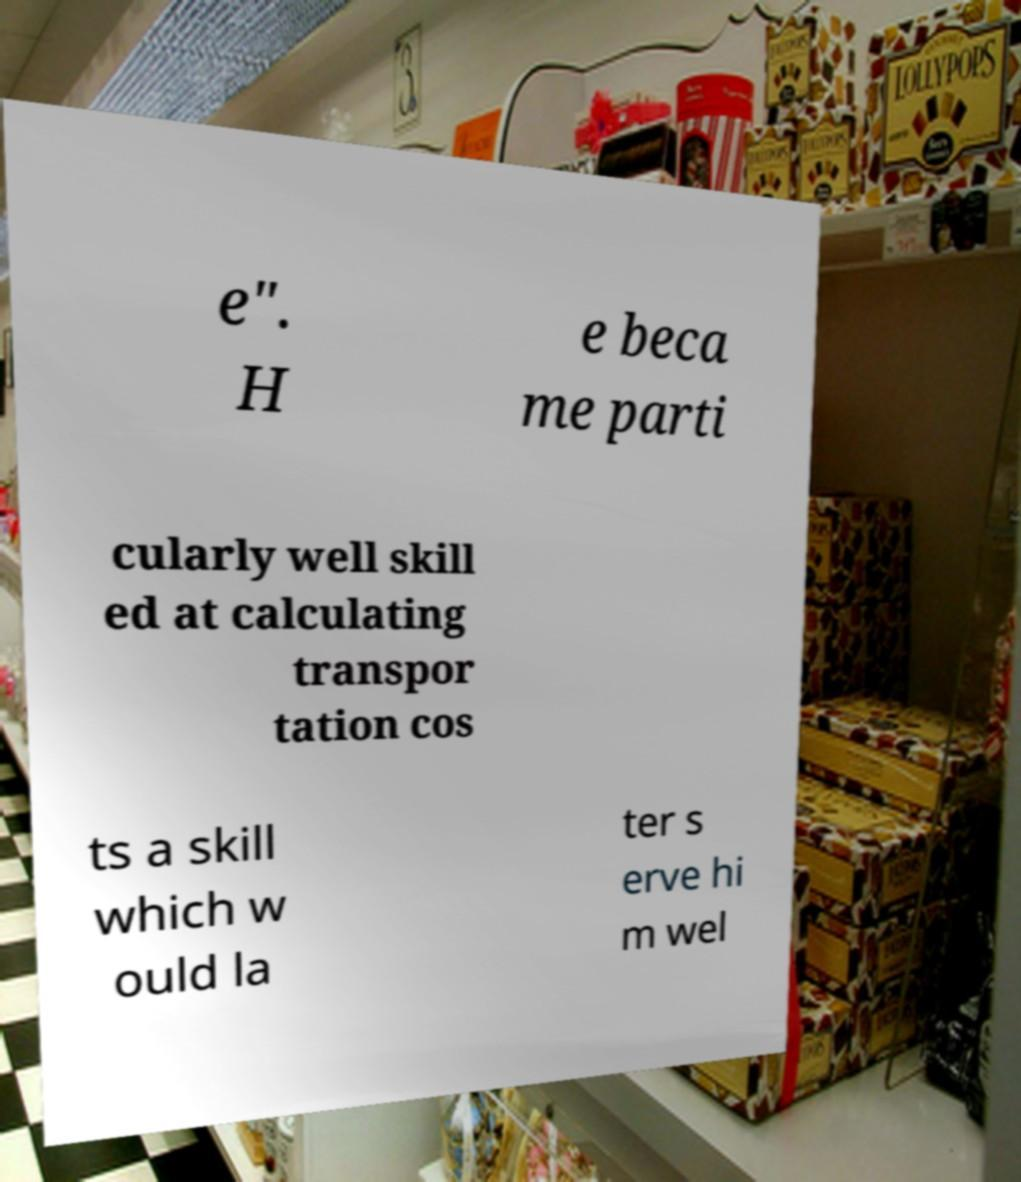Could you assist in decoding the text presented in this image and type it out clearly? e". H e beca me parti cularly well skill ed at calculating transpor tation cos ts a skill which w ould la ter s erve hi m wel 